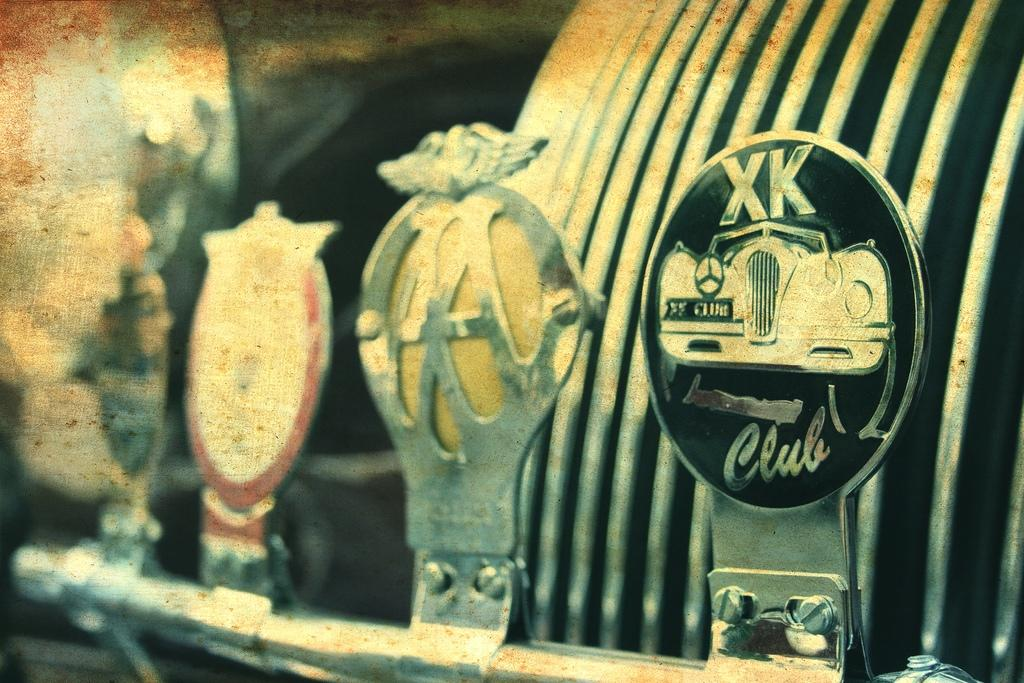What type of materials are the objects in the image made up of? The objects in the image are made up of metals. Can you tell me how many dogs are being measured by the stranger in the image? There is no stranger or dogs present in the image; it only features objects made up of metals. 